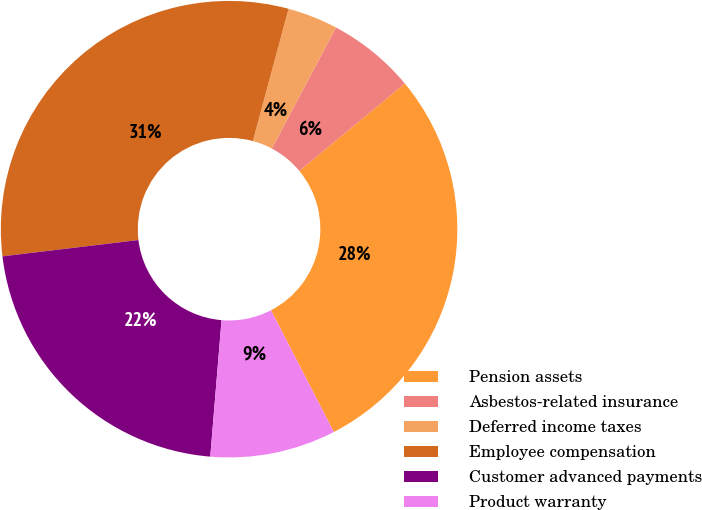Convert chart to OTSL. <chart><loc_0><loc_0><loc_500><loc_500><pie_chart><fcel>Pension assets<fcel>Asbestos-related insurance<fcel>Deferred income taxes<fcel>Employee compensation<fcel>Customer advanced payments<fcel>Product warranty<nl><fcel>28.43%<fcel>6.23%<fcel>3.56%<fcel>31.1%<fcel>21.79%<fcel>8.9%<nl></chart> 